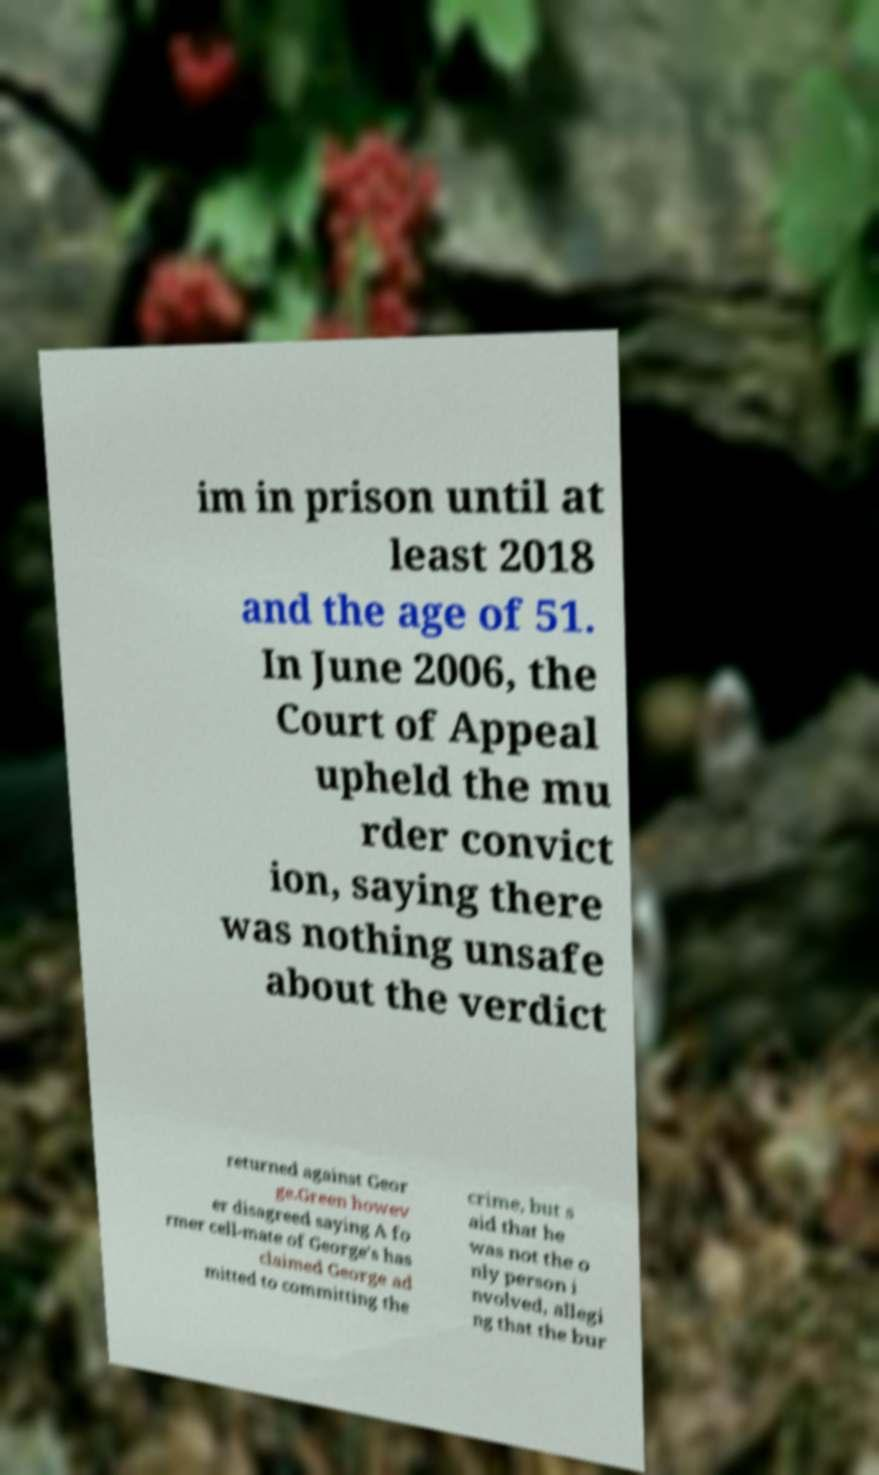Could you assist in decoding the text presented in this image and type it out clearly? im in prison until at least 2018 and the age of 51. In June 2006, the Court of Appeal upheld the mu rder convict ion, saying there was nothing unsafe about the verdict returned against Geor ge.Green howev er disagreed saying A fo rmer cell-mate of George's has claimed George ad mitted to committing the crime, but s aid that he was not the o nly person i nvolved, allegi ng that the bur 